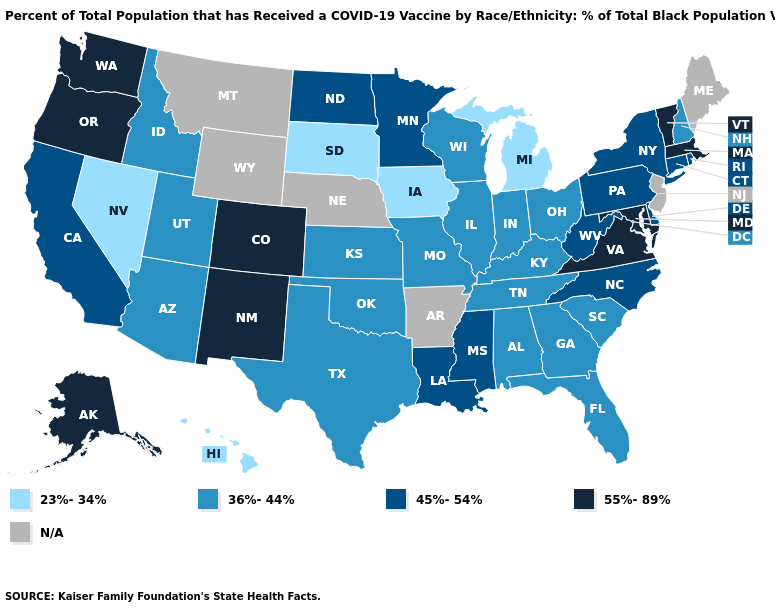What is the value of Indiana?
Answer briefly. 36%-44%. What is the value of West Virginia?
Write a very short answer. 45%-54%. Does Hawaii have the lowest value in the USA?
Be succinct. Yes. What is the value of Wisconsin?
Be succinct. 36%-44%. Among the states that border Nevada , does Utah have the highest value?
Write a very short answer. No. Which states have the highest value in the USA?
Concise answer only. Alaska, Colorado, Maryland, Massachusetts, New Mexico, Oregon, Vermont, Virginia, Washington. How many symbols are there in the legend?
Write a very short answer. 5. Does Washington have the highest value in the USA?
Concise answer only. Yes. What is the value of Vermont?
Quick response, please. 55%-89%. What is the value of Nevada?
Be succinct. 23%-34%. What is the lowest value in the West?
Quick response, please. 23%-34%. Name the states that have a value in the range 36%-44%?
Write a very short answer. Alabama, Arizona, Florida, Georgia, Idaho, Illinois, Indiana, Kansas, Kentucky, Missouri, New Hampshire, Ohio, Oklahoma, South Carolina, Tennessee, Texas, Utah, Wisconsin. Name the states that have a value in the range 45%-54%?
Keep it brief. California, Connecticut, Delaware, Louisiana, Minnesota, Mississippi, New York, North Carolina, North Dakota, Pennsylvania, Rhode Island, West Virginia. Name the states that have a value in the range 55%-89%?
Give a very brief answer. Alaska, Colorado, Maryland, Massachusetts, New Mexico, Oregon, Vermont, Virginia, Washington. 